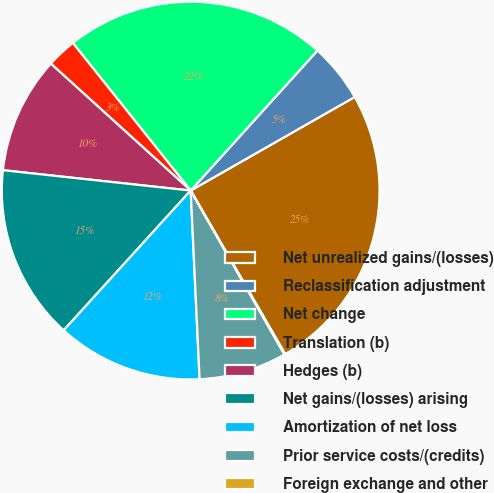Convert chart to OTSL. <chart><loc_0><loc_0><loc_500><loc_500><pie_chart><fcel>Net unrealized gains/(losses)<fcel>Reclassification adjustment<fcel>Net change<fcel>Translation (b)<fcel>Hedges (b)<fcel>Net gains/(losses) arising<fcel>Amortization of net loss<fcel>Prior service costs/(credits)<fcel>Foreign exchange and other<nl><fcel>24.91%<fcel>5.04%<fcel>22.43%<fcel>2.55%<fcel>10.01%<fcel>14.98%<fcel>12.49%<fcel>7.52%<fcel>0.07%<nl></chart> 